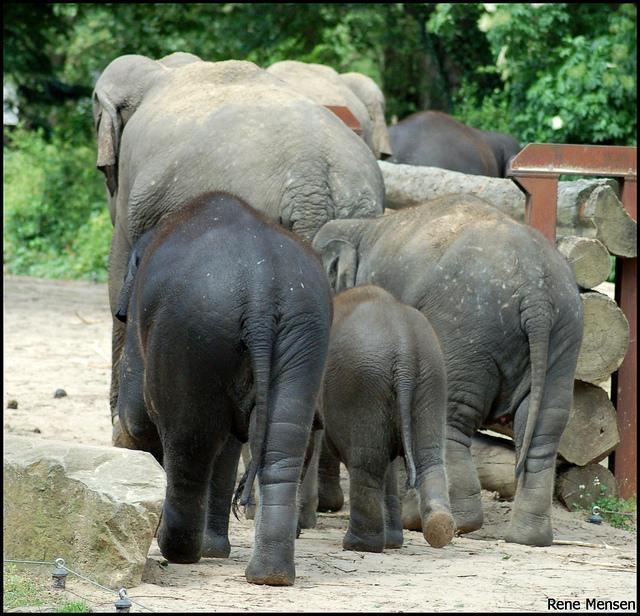What is this group of animals called?
Indicate the correct choice and explain in the format: 'Answer: answer
Rationale: rationale.'
Options: Clowder, school, herd, pride. Answer: herd.
Rationale: There is a group of elephants. 